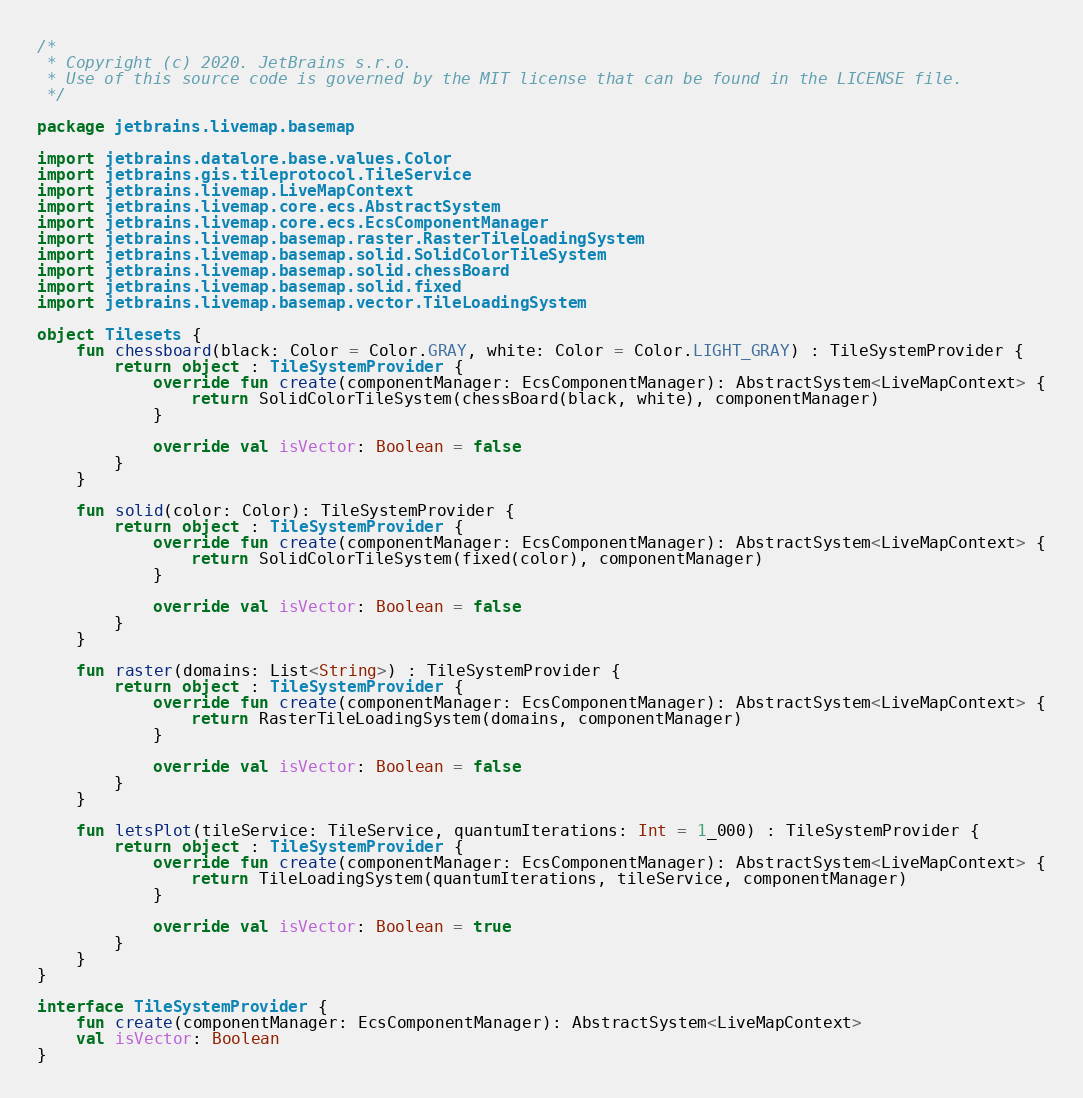Convert code to text. <code><loc_0><loc_0><loc_500><loc_500><_Kotlin_>/*
 * Copyright (c) 2020. JetBrains s.r.o.
 * Use of this source code is governed by the MIT license that can be found in the LICENSE file.
 */

package jetbrains.livemap.basemap

import jetbrains.datalore.base.values.Color
import jetbrains.gis.tileprotocol.TileService
import jetbrains.livemap.LiveMapContext
import jetbrains.livemap.core.ecs.AbstractSystem
import jetbrains.livemap.core.ecs.EcsComponentManager
import jetbrains.livemap.basemap.raster.RasterTileLoadingSystem
import jetbrains.livemap.basemap.solid.SolidColorTileSystem
import jetbrains.livemap.basemap.solid.chessBoard
import jetbrains.livemap.basemap.solid.fixed
import jetbrains.livemap.basemap.vector.TileLoadingSystem

object Tilesets {
    fun chessboard(black: Color = Color.GRAY, white: Color = Color.LIGHT_GRAY) : TileSystemProvider {
        return object : TileSystemProvider {
            override fun create(componentManager: EcsComponentManager): AbstractSystem<LiveMapContext> {
                return SolidColorTileSystem(chessBoard(black, white), componentManager)
            }

            override val isVector: Boolean = false
        }
    }

    fun solid(color: Color): TileSystemProvider {
        return object : TileSystemProvider {
            override fun create(componentManager: EcsComponentManager): AbstractSystem<LiveMapContext> {
                return SolidColorTileSystem(fixed(color), componentManager)
            }

            override val isVector: Boolean = false
        }
    }

    fun raster(domains: List<String>) : TileSystemProvider {
        return object : TileSystemProvider {
            override fun create(componentManager: EcsComponentManager): AbstractSystem<LiveMapContext> {
                return RasterTileLoadingSystem(domains, componentManager)
            }

            override val isVector: Boolean = false
        }
    }

    fun letsPlot(tileService: TileService, quantumIterations: Int = 1_000) : TileSystemProvider {
        return object : TileSystemProvider {
            override fun create(componentManager: EcsComponentManager): AbstractSystem<LiveMapContext> {
                return TileLoadingSystem(quantumIterations, tileService, componentManager)
            }

            override val isVector: Boolean = true
        }
    }
}

interface TileSystemProvider {
    fun create(componentManager: EcsComponentManager): AbstractSystem<LiveMapContext>
    val isVector: Boolean
}
</code> 